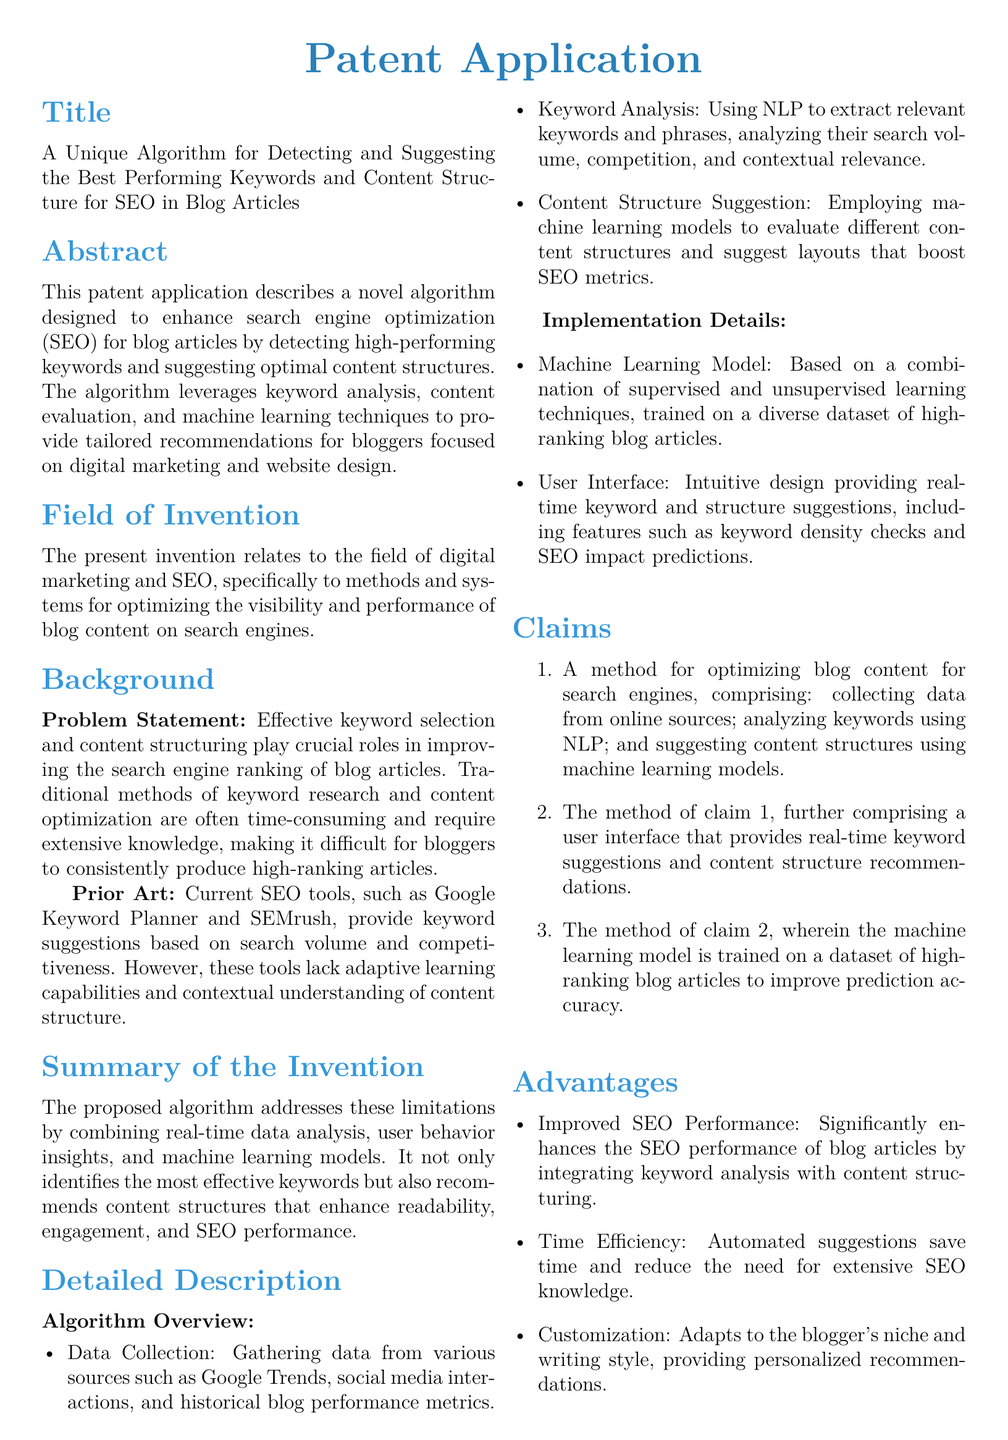What is the title of the patent application? The title is found under the "Title" section of the document.
Answer: A Unique Algorithm for Detecting and Suggesting the Best Performing Keywords and Content Structure for SEO in Blog Articles What is the main problem addressed by the invention? The problem statement in the "Background" section outlines the main issue.
Answer: Effective keyword selection and content structuring What techniques does the algorithm use for keyword analysis? The "Detailed Description" section specifies the method used for keyword analysis.
Answer: NLP What does the user interface provide? The claims section details the functionality of the user interface.
Answer: Real-time keyword suggestions and content structure recommendations What data sources are mentioned for data collection? The algorithm overview lists sources for gathering data.
Answer: Google Trends, social media interactions, and historical blog performance metrics How does the algorithm enhance SEO performance? The advantages section explains the benefit of the algorithm.
Answer: Integrating keyword analysis with content structuring What type of machine learning model is used? The implementation details elaborate on the model used.
Answer: A combination of supervised and unsupervised learning techniques What is one of the advantages of this algorithm? The advantages section highlights specific benefits of the algorithm.
Answer: Time Efficiency What does claim 1 involve? The claims section describes the method outlined in claim 1.
Answer: Collecting data from online sources; analyzing keywords using NLP; and suggesting content structures using machine learning models 